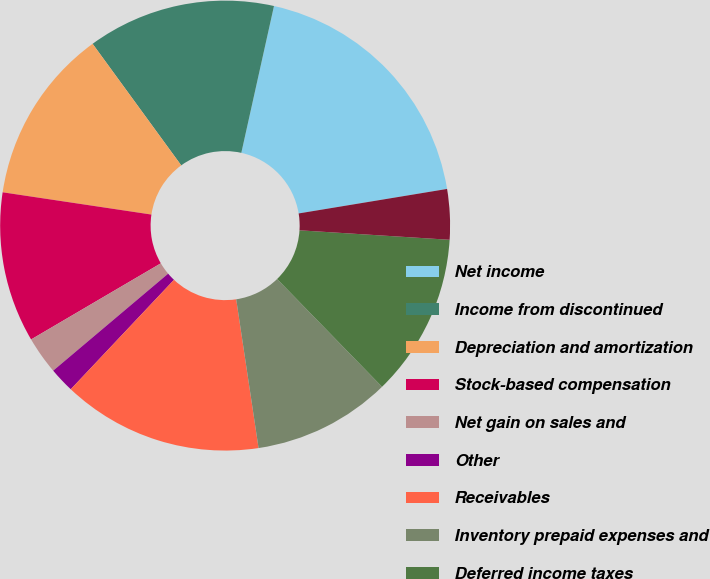Convert chart to OTSL. <chart><loc_0><loc_0><loc_500><loc_500><pie_chart><fcel>Net income<fcel>Income from discontinued<fcel>Depreciation and amortization<fcel>Stock-based compensation<fcel>Net gain on sales and<fcel>Other<fcel>Receivables<fcel>Inventory prepaid expenses and<fcel>Deferred income taxes<fcel>Other assets<nl><fcel>18.91%<fcel>13.51%<fcel>12.61%<fcel>10.81%<fcel>2.71%<fcel>1.81%<fcel>14.41%<fcel>9.91%<fcel>11.71%<fcel>3.61%<nl></chart> 